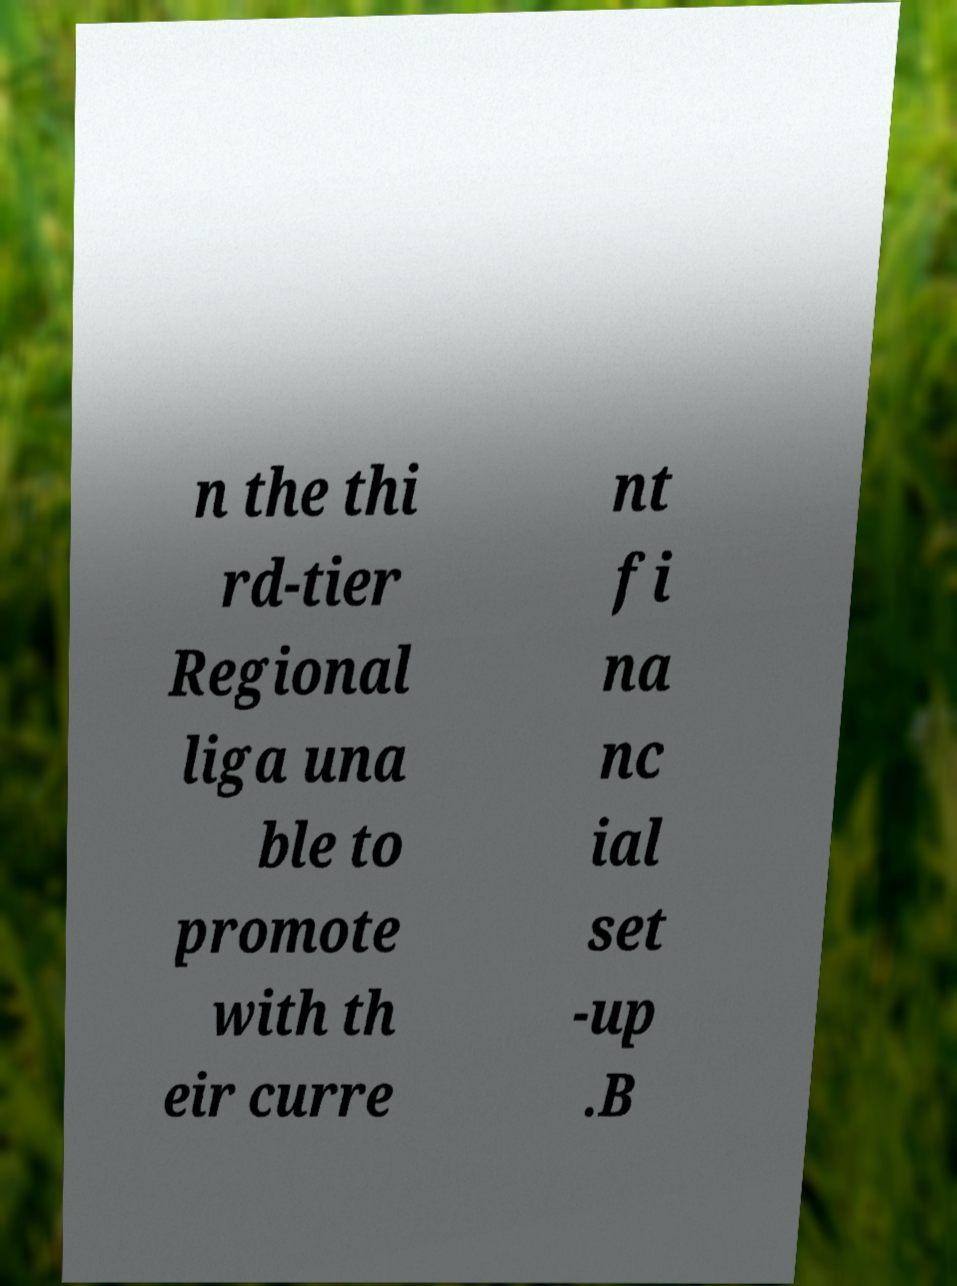I need the written content from this picture converted into text. Can you do that? n the thi rd-tier Regional liga una ble to promote with th eir curre nt fi na nc ial set -up .B 